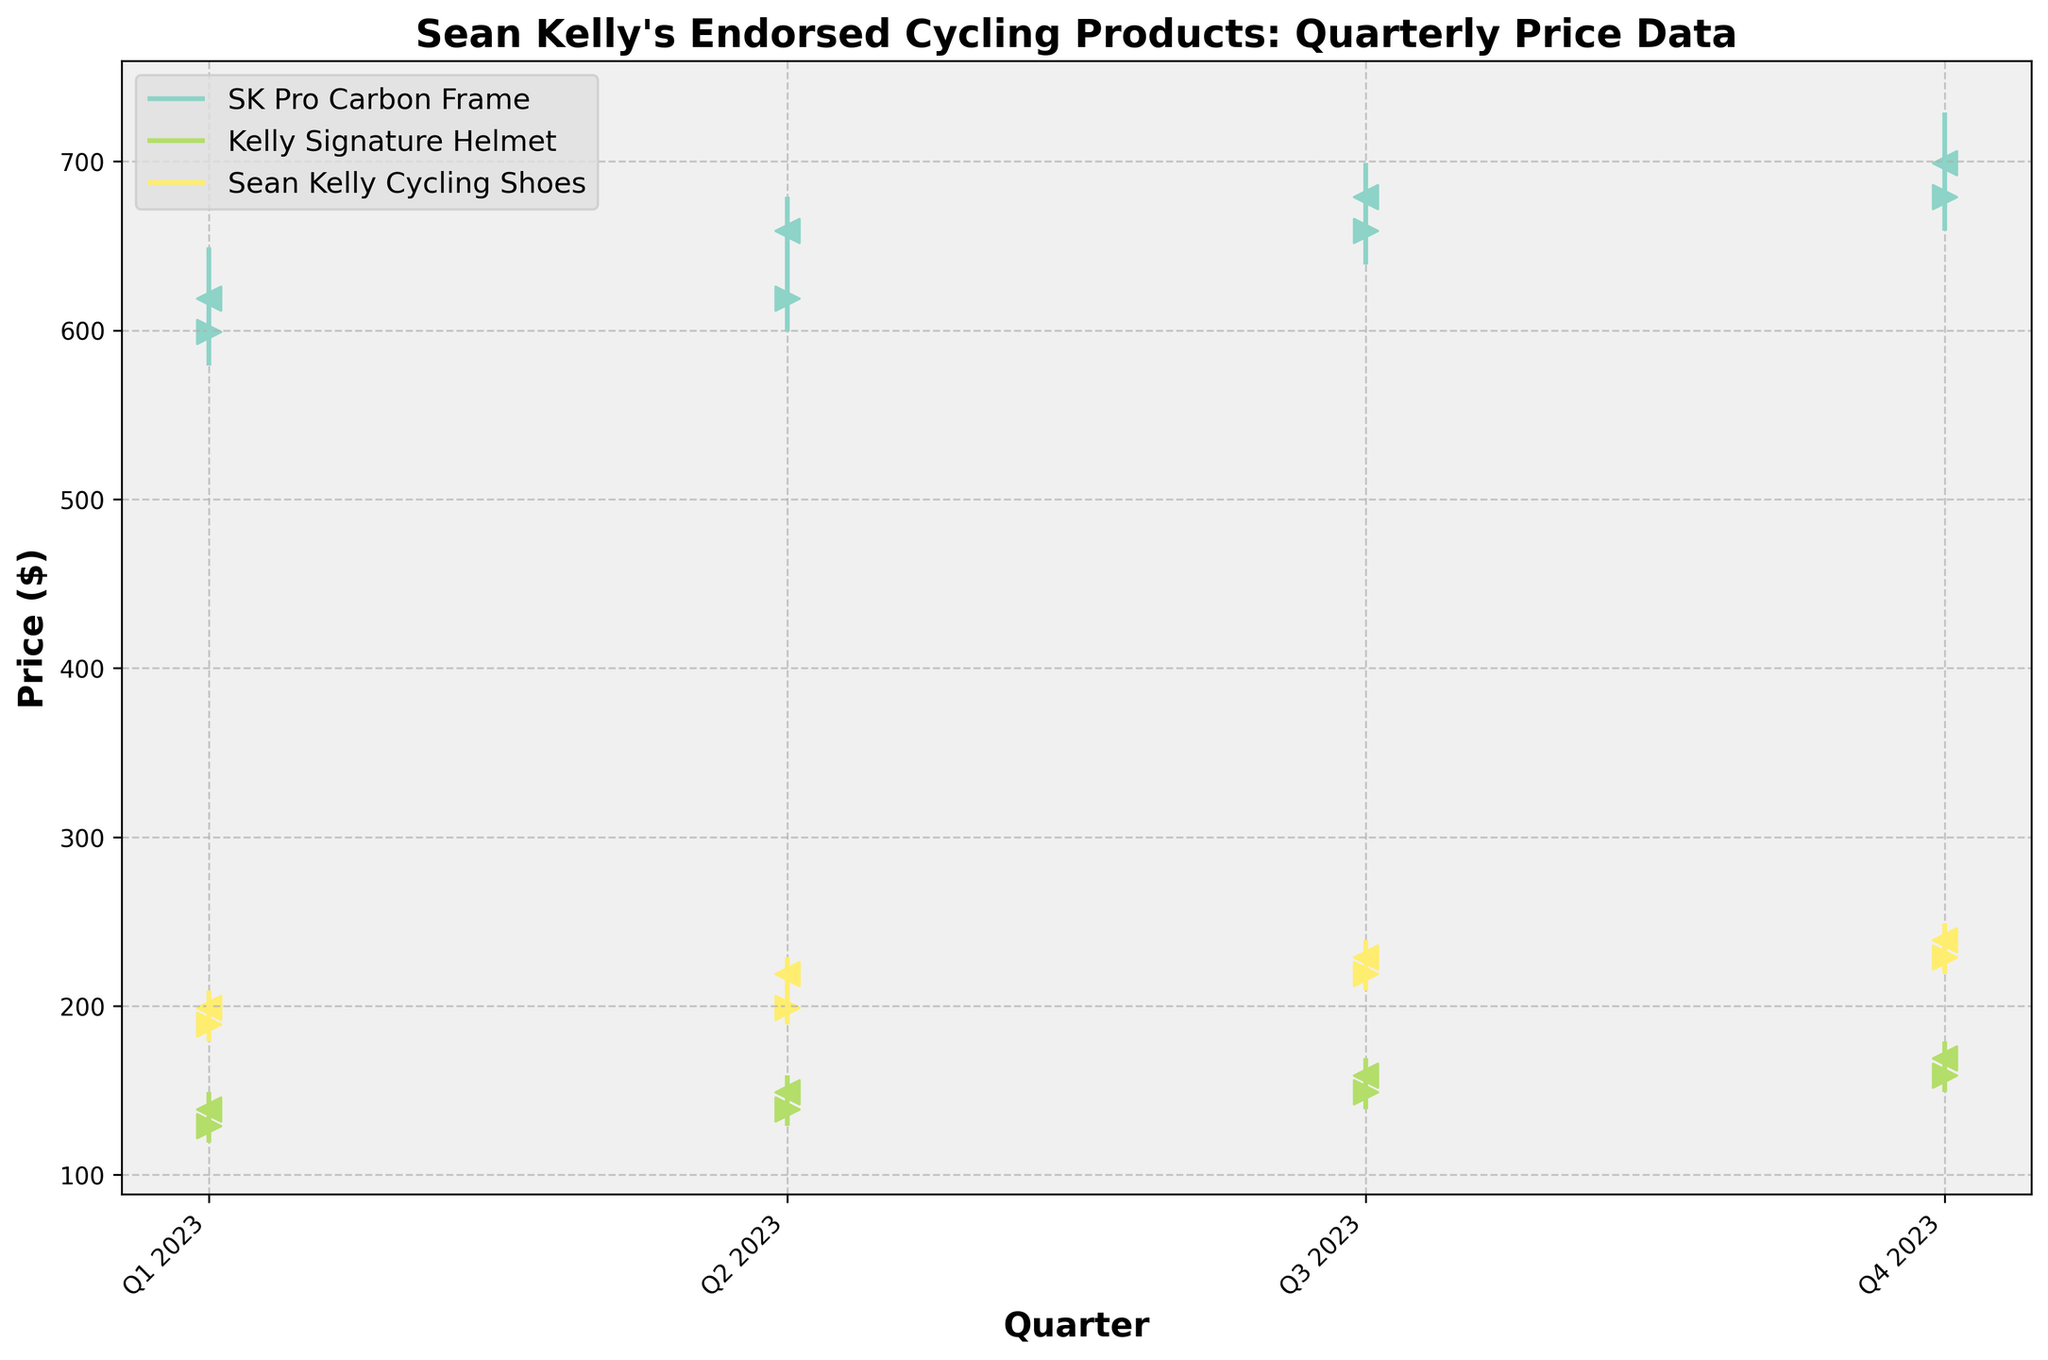How many different products are displayed in the figure? There are three unique products in the dataset: 'SK Pro Carbon Frame', 'Kelly Signature Helmet', and 'Sean Kelly Cycling Shoes'. Just count the different labels in the legend.
Answer: 3 Which product had the highest closing price in Q3 2023? For Q3 2023, you need to compare the 'Close' prices of each product. The 'SK Pro Carbon Frame' closed at 679, 'Kelly Signature Helmet' closed at 159, and 'Sean Kelly Cycling Shoes' closed at 229. The 'SK Pro Carbon Frame' had the highest closing price.
Answer: SK Pro Carbon Frame What is the average closing price of 'Kelly Signature Helmet' over all quarters? Add the closing prices of 'Kelly Signature Helmet' for all quarters: 139 (Q1) + 149 (Q2) + 159 (Q3) + 169 (Q4) = 616. Then divide by the number of quarters, which is 4. 616 / 4 = 154.
Answer: 154 Which product shows the greatest increase in closing price from Q1 to Q4 2023? Calculate the difference in closing prices from Q1 to Q4 for each product: 
- SK Pro Carbon Frame: 699 - 619 = 80 
- Kelly Signature Helmet: 169 - 139 = 30 
- Sean Kelly Cycling Shoes: 239 - 199 = 40 
The 'SK Pro Carbon Frame' shows the greatest increase.
Answer: SK Pro Carbon Frame During which quarter did 'Sean Kelly Cycling Shoes' reach their highest price? Compare the 'High' prices for each quarter: 209 (Q1), 229 (Q2), 239 (Q3), and 249 (Q4). The highest price of 249 occurred in Q4.
Answer: Q4 2023 What was the closing price of 'SK Pro Carbon Frame' in Q2 2023? Look at the closing price of 'SK Pro Carbon Frame' for Q2 2023 in the dataset, which is 659.
Answer: 659 How does the closing price for 'Kelly Signature Helmet' in Q4 compare to its opening price in the same quarter? The closing price for 'Kelly Signature Helmet' in Q4 is 169, and the opening price is 159. The closing price is higher than the opening price by 10 units.
Answer: Higher by 10 Between Q2 and Q3, which product had the smallest change in closing price? Calculate the changes in closing prices:
- SK Pro Carbon Frame: 679 - 659 = 20 
- Kelly Signature Helmet: 159 - 149 = 10 
- Sean Kelly Cycling Shoes: 229 - 219 = 10 
Both 'Kelly Signature Helmet' and 'Sean Kelly Cycling Shoes' had the smallest change in closing price, with a change of 10 units.
Answer: Kelly Signature Helmet and Sean Kelly Cycling Shoes What is the difference between the highest and lowest prices of 'SK Pro Carbon Frame' in Q4 2023? For 'SK Pro Carbon Frame' in Q4 2023, the highest price is 729 and the lowest price is 659. The difference is 729 - 659 = 70.
Answer: 70 What was the highest recorded price for 'Sean Kelly Cycling Shoes' in the given data? Scan the 'High' prices for 'Sean Kelly Cycling Shoes' across all quarters: 209 (Q1), 229 (Q2), 239 (Q3), and 249 (Q4). The highest recorded price is 249 in Q4.
Answer: 249 